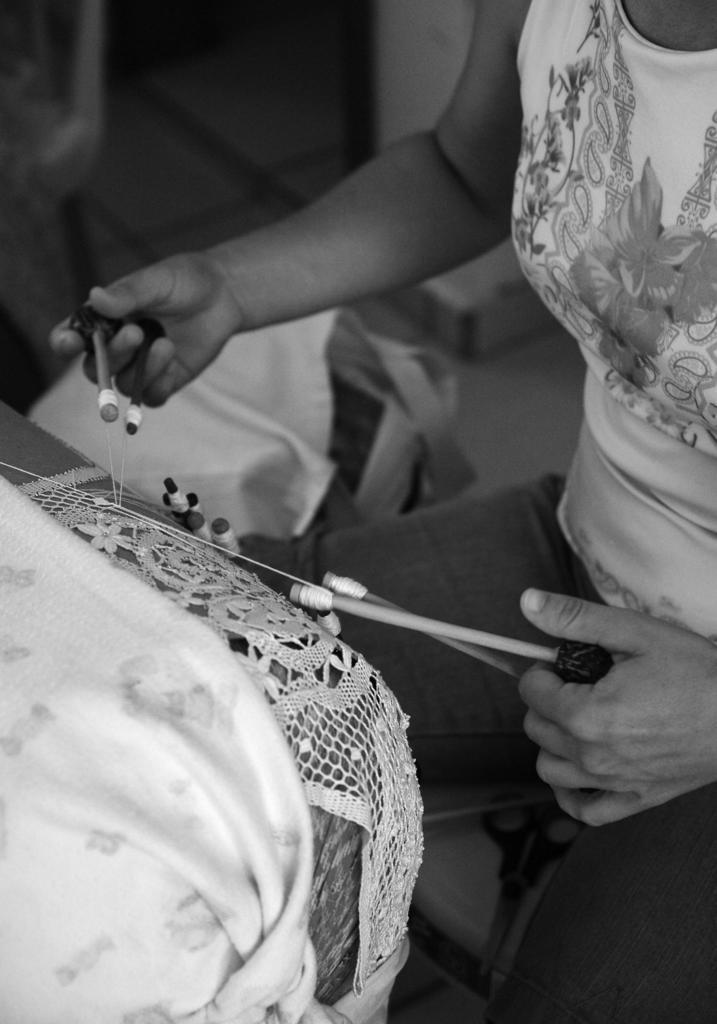Please provide a concise description of this image. There is a person on the right side of the image he is doing thread work and there is a sofa on the left side. There are some objects in the background area. 